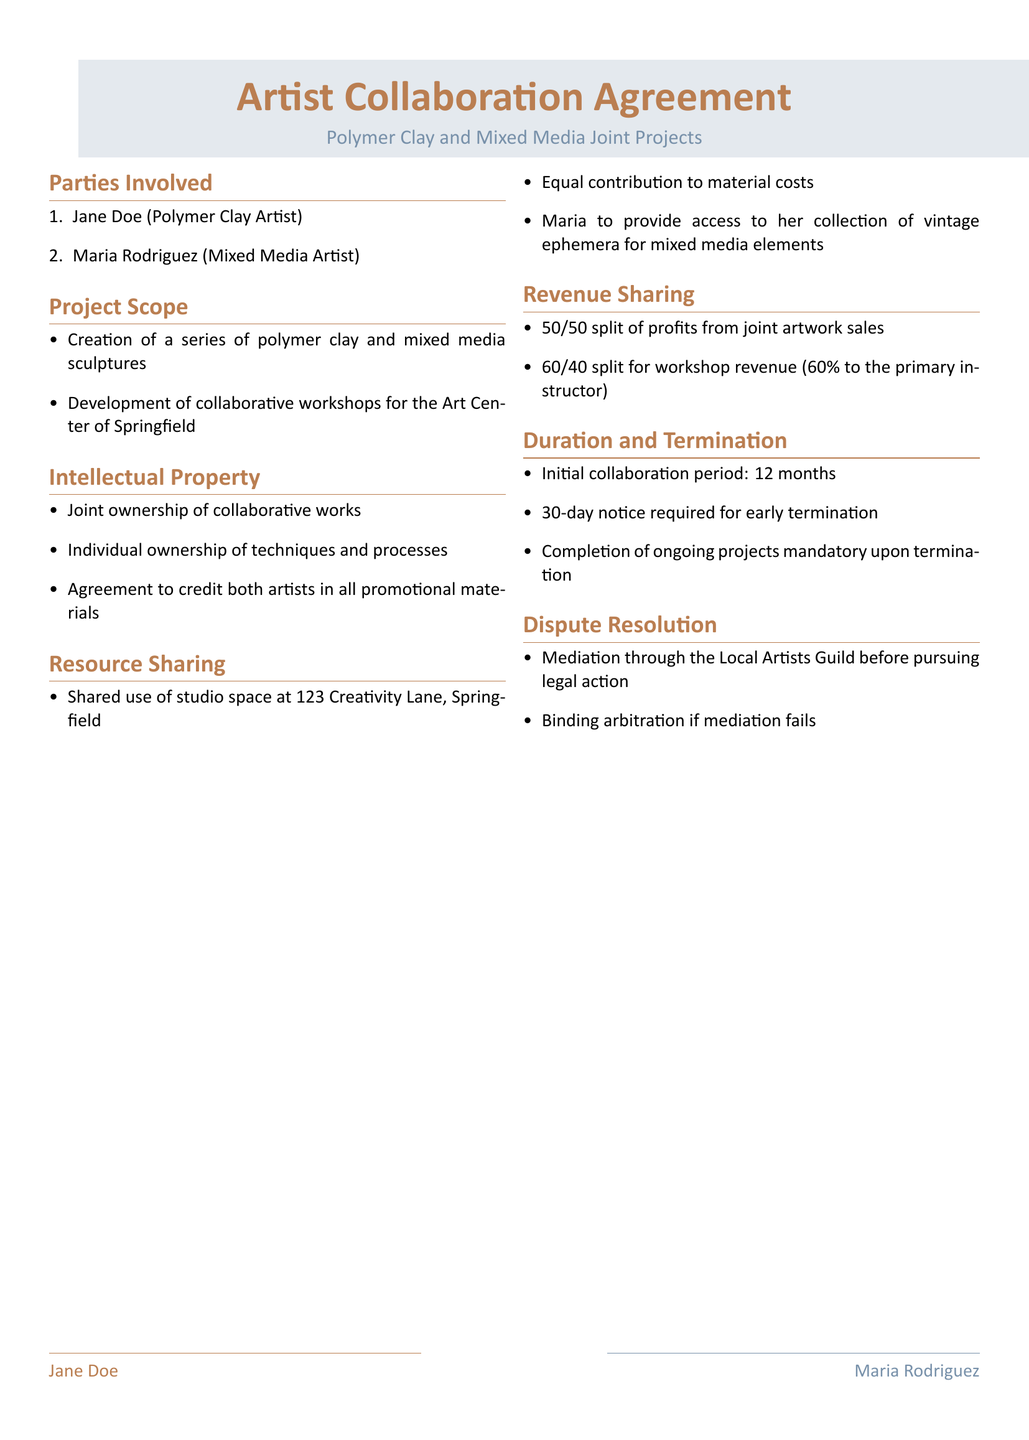What are the names of the parties involved? The parties involved are directly listed under the "Parties Involved" section, which contains the names Jane Doe and Maria Rodriguez.
Answer: Jane Doe, Maria Rodriguez How long is the initial collaboration period? The duration of the initial collaboration period is explicitly stated in the "Duration and Termination" section as 12 months.
Answer: 12 months What is the revenue split for workshop revenue? The specific revenue split for workshop revenue is outlined in the "Revenue Sharing" section, which indicates a 60/40 split.
Answer: 60/40 What type of projects are included in the project scope? The "Project Scope" section specifies the types of projects, which include creation of sculptures and development of workshops.
Answer: Sculptures, Workshops What is required for early termination of the agreement? The document mentions in the "Duration and Termination" section that a 30-day notice is required for early termination.
Answer: 30-day notice What is the method of dispute resolution mentioned? The "Dispute Resolution" section states that mediation through the Local Artists Guild is the initial method before legal action.
Answer: Mediation Who is responsible for providing access to vintage ephemera? The "Resource Sharing" section identifies Maria as the party responsible for providing access to vintage ephemera.
Answer: Maria What does the agreement say about crediting artists? The "Intellectual Property" section mandates that both artists receive credit in all promotional materials.
Answer: Credit both artists How are the profits from artwork sales shared? The "Revenue Sharing" section specifies that profits from artwork sales are split 50/50.
Answer: 50/50 